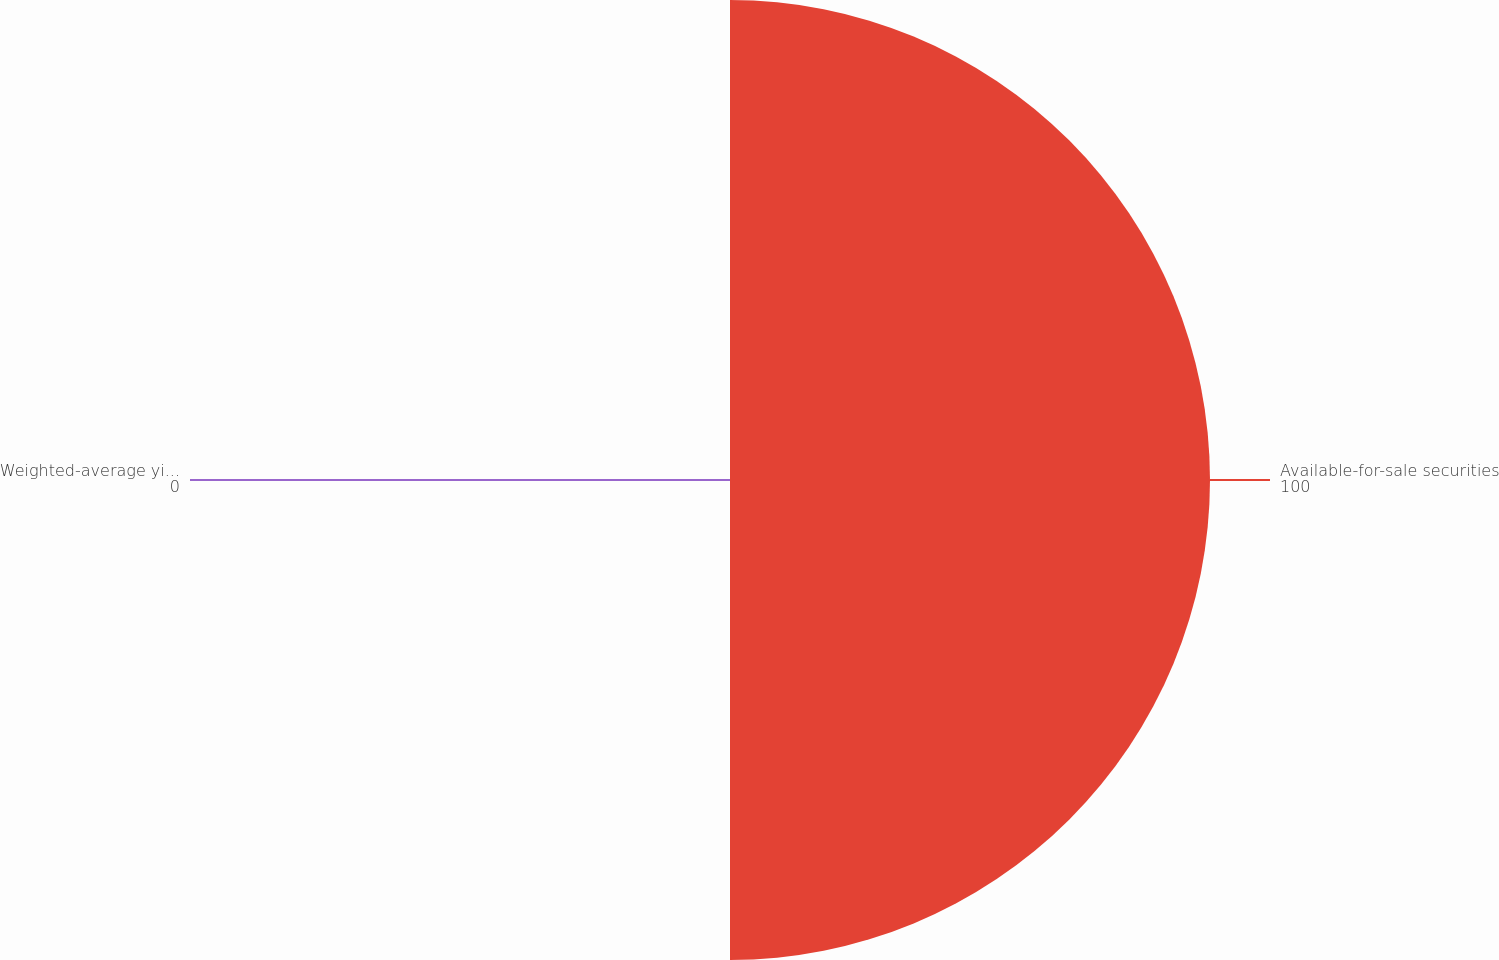Convert chart. <chart><loc_0><loc_0><loc_500><loc_500><pie_chart><fcel>Available-for-sale securities<fcel>Weighted-average yield rate<nl><fcel>100.0%<fcel>0.0%<nl></chart> 